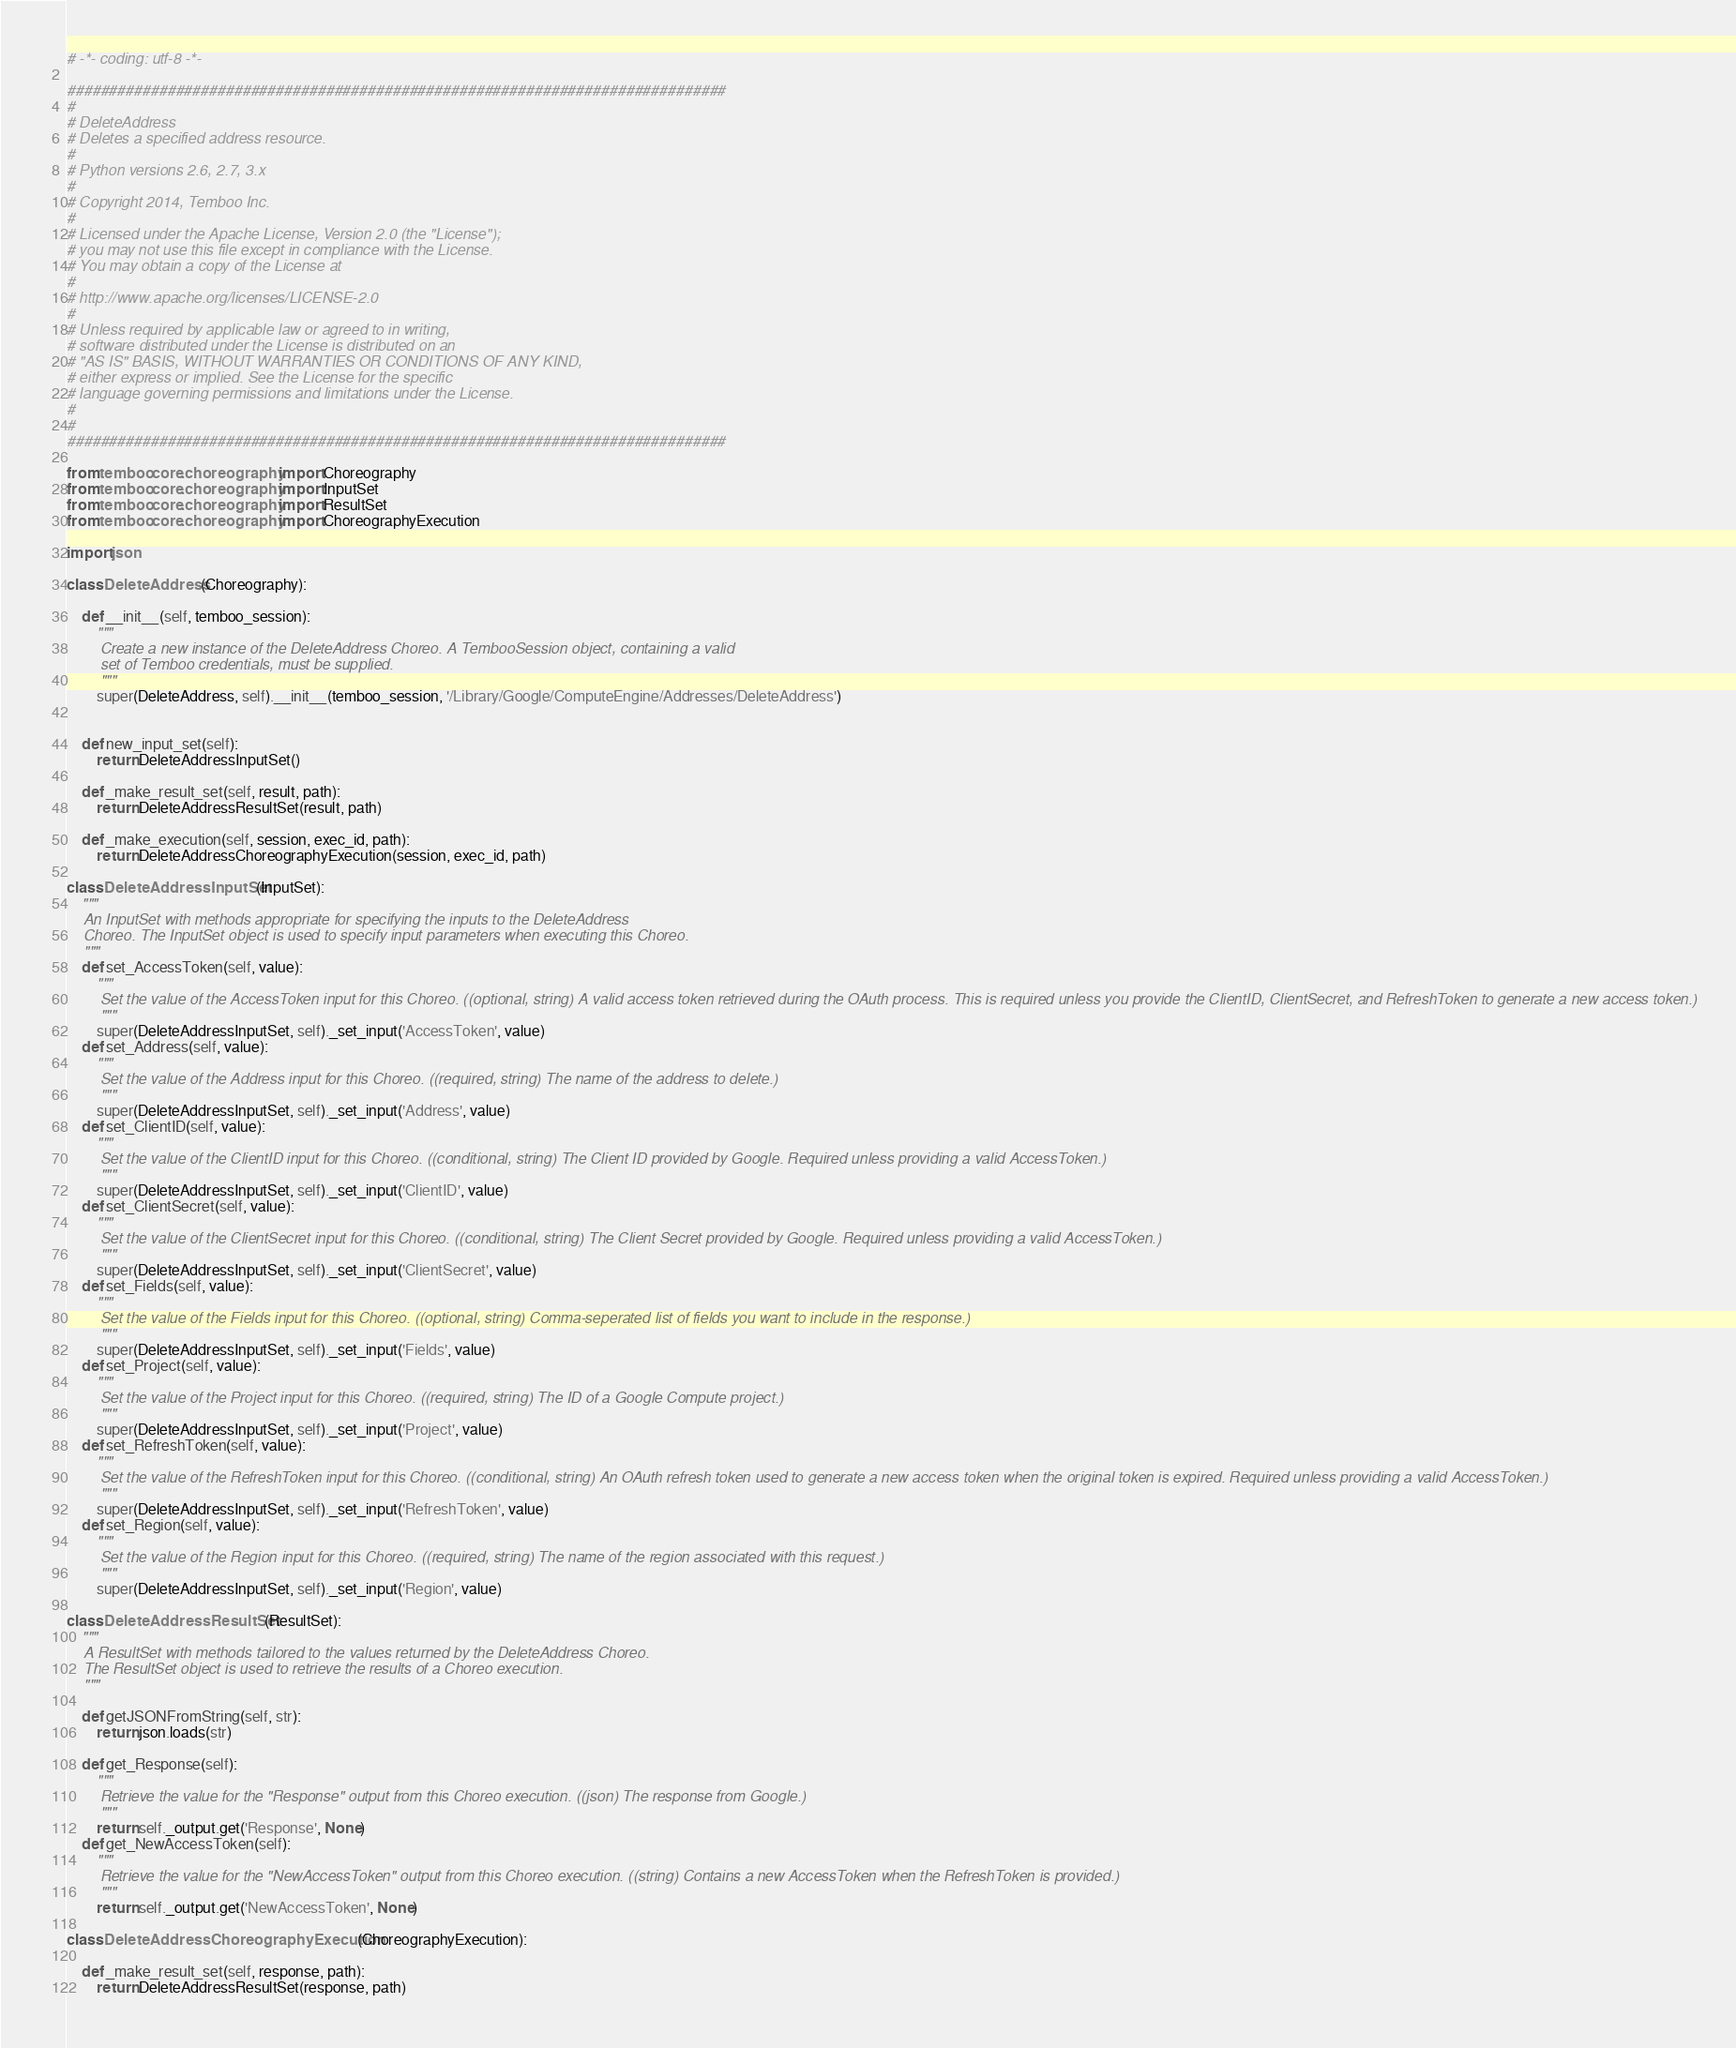<code> <loc_0><loc_0><loc_500><loc_500><_Python_># -*- coding: utf-8 -*-

###############################################################################
#
# DeleteAddress
# Deletes a specified address resource.
#
# Python versions 2.6, 2.7, 3.x
#
# Copyright 2014, Temboo Inc.
#
# Licensed under the Apache License, Version 2.0 (the "License");
# you may not use this file except in compliance with the License.
# You may obtain a copy of the License at
#
# http://www.apache.org/licenses/LICENSE-2.0
#
# Unless required by applicable law or agreed to in writing,
# software distributed under the License is distributed on an
# "AS IS" BASIS, WITHOUT WARRANTIES OR CONDITIONS OF ANY KIND,
# either express or implied. See the License for the specific
# language governing permissions and limitations under the License.
#
#
###############################################################################

from temboo.core.choreography import Choreography
from temboo.core.choreography import InputSet
from temboo.core.choreography import ResultSet
from temboo.core.choreography import ChoreographyExecution

import json

class DeleteAddress(Choreography):

    def __init__(self, temboo_session):
        """
        Create a new instance of the DeleteAddress Choreo. A TembooSession object, containing a valid
        set of Temboo credentials, must be supplied.
        """
        super(DeleteAddress, self).__init__(temboo_session, '/Library/Google/ComputeEngine/Addresses/DeleteAddress')


    def new_input_set(self):
        return DeleteAddressInputSet()

    def _make_result_set(self, result, path):
        return DeleteAddressResultSet(result, path)

    def _make_execution(self, session, exec_id, path):
        return DeleteAddressChoreographyExecution(session, exec_id, path)

class DeleteAddressInputSet(InputSet):
    """
    An InputSet with methods appropriate for specifying the inputs to the DeleteAddress
    Choreo. The InputSet object is used to specify input parameters when executing this Choreo.
    """
    def set_AccessToken(self, value):
        """
        Set the value of the AccessToken input for this Choreo. ((optional, string) A valid access token retrieved during the OAuth process. This is required unless you provide the ClientID, ClientSecret, and RefreshToken to generate a new access token.)
        """
        super(DeleteAddressInputSet, self)._set_input('AccessToken', value)
    def set_Address(self, value):
        """
        Set the value of the Address input for this Choreo. ((required, string) The name of the address to delete.)
        """
        super(DeleteAddressInputSet, self)._set_input('Address', value)
    def set_ClientID(self, value):
        """
        Set the value of the ClientID input for this Choreo. ((conditional, string) The Client ID provided by Google. Required unless providing a valid AccessToken.)
        """
        super(DeleteAddressInputSet, self)._set_input('ClientID', value)
    def set_ClientSecret(self, value):
        """
        Set the value of the ClientSecret input for this Choreo. ((conditional, string) The Client Secret provided by Google. Required unless providing a valid AccessToken.)
        """
        super(DeleteAddressInputSet, self)._set_input('ClientSecret', value)
    def set_Fields(self, value):
        """
        Set the value of the Fields input for this Choreo. ((optional, string) Comma-seperated list of fields you want to include in the response.)
        """
        super(DeleteAddressInputSet, self)._set_input('Fields', value)
    def set_Project(self, value):
        """
        Set the value of the Project input for this Choreo. ((required, string) The ID of a Google Compute project.)
        """
        super(DeleteAddressInputSet, self)._set_input('Project', value)
    def set_RefreshToken(self, value):
        """
        Set the value of the RefreshToken input for this Choreo. ((conditional, string) An OAuth refresh token used to generate a new access token when the original token is expired. Required unless providing a valid AccessToken.)
        """
        super(DeleteAddressInputSet, self)._set_input('RefreshToken', value)
    def set_Region(self, value):
        """
        Set the value of the Region input for this Choreo. ((required, string) The name of the region associated with this request.)
        """
        super(DeleteAddressInputSet, self)._set_input('Region', value)

class DeleteAddressResultSet(ResultSet):
    """
    A ResultSet with methods tailored to the values returned by the DeleteAddress Choreo.
    The ResultSet object is used to retrieve the results of a Choreo execution.
    """

    def getJSONFromString(self, str):
        return json.loads(str)

    def get_Response(self):
        """
        Retrieve the value for the "Response" output from this Choreo execution. ((json) The response from Google.)
        """
        return self._output.get('Response', None)
    def get_NewAccessToken(self):
        """
        Retrieve the value for the "NewAccessToken" output from this Choreo execution. ((string) Contains a new AccessToken when the RefreshToken is provided.)
        """
        return self._output.get('NewAccessToken', None)

class DeleteAddressChoreographyExecution(ChoreographyExecution):

    def _make_result_set(self, response, path):
        return DeleteAddressResultSet(response, path)
</code> 